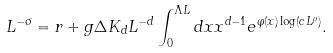<formula> <loc_0><loc_0><loc_500><loc_500>L ^ { - \sigma } = r + g \Delta K _ { d } L ^ { - d } \int _ { 0 } ^ { \Lambda L } d x x ^ { d - 1 } e ^ { \varphi ( x ) \log ( c L ^ { \rho } ) } .</formula> 